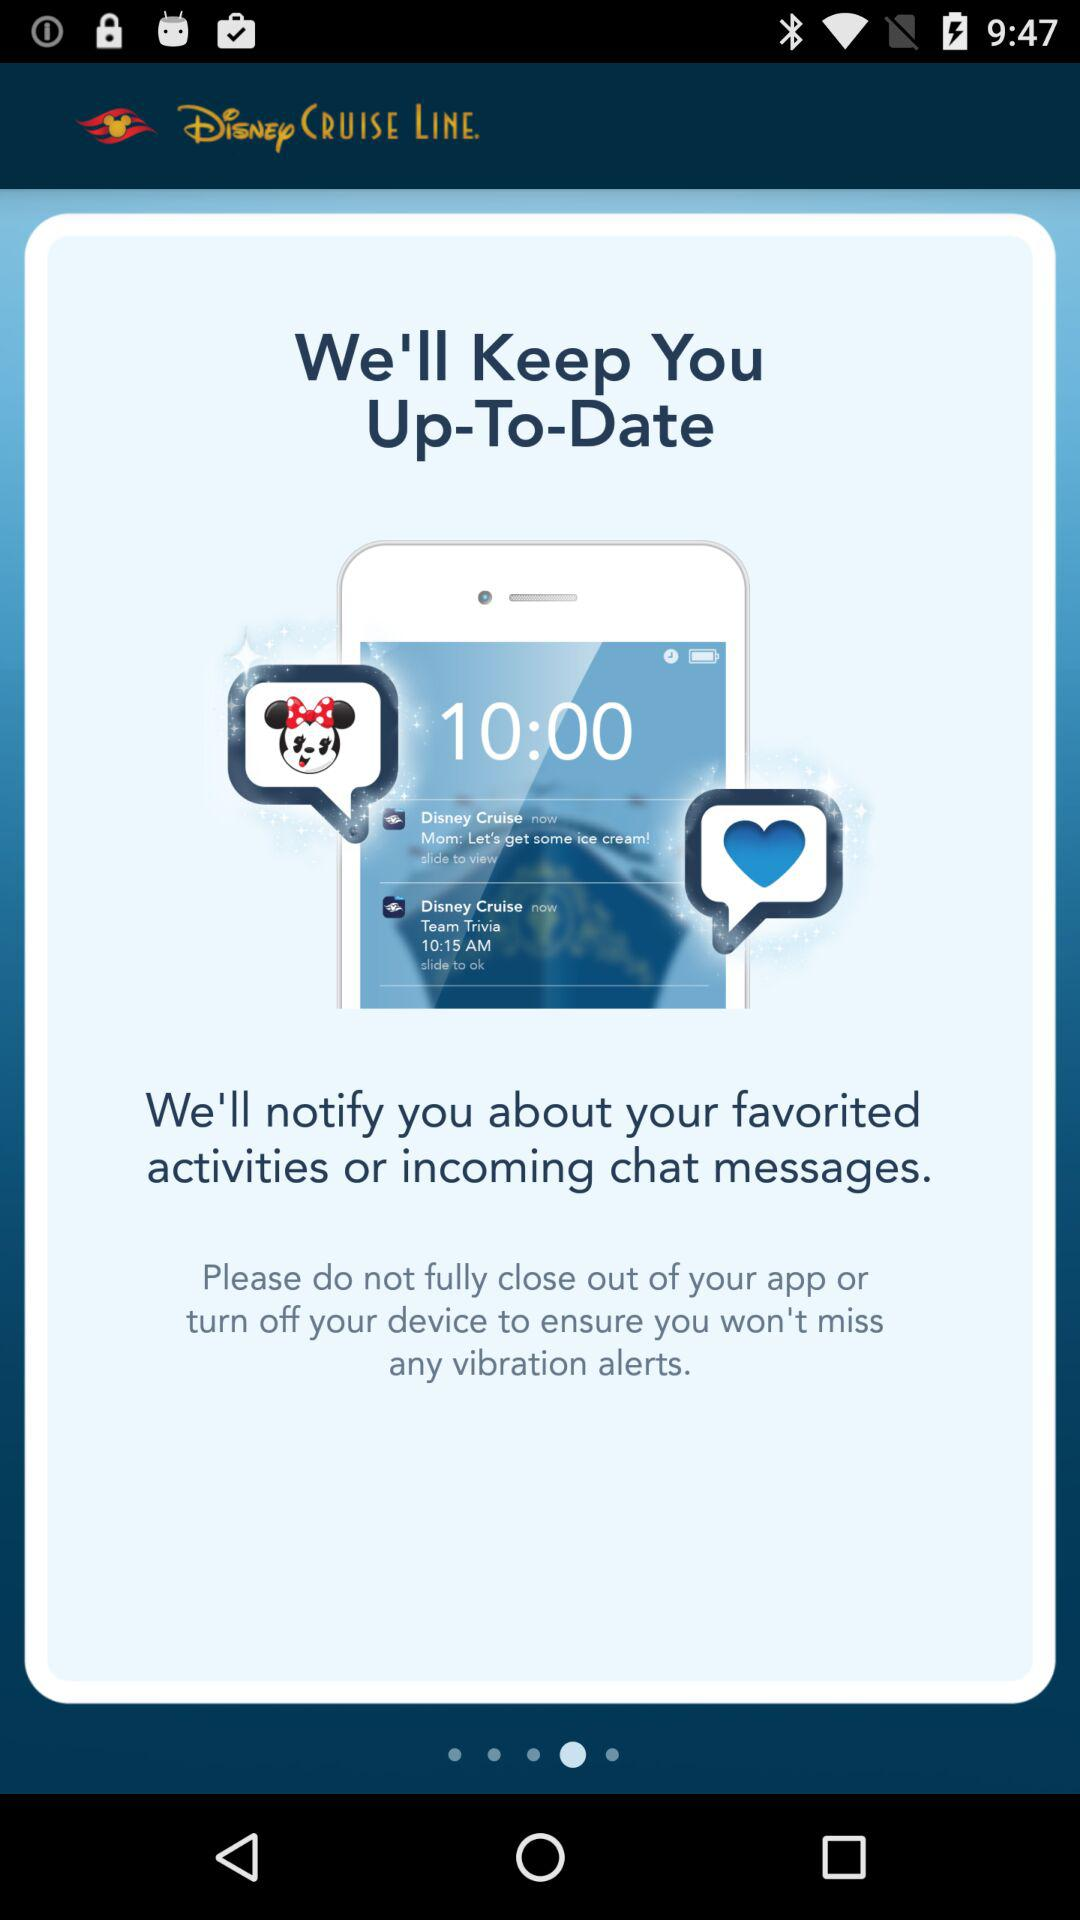What time is shown on the screen? The time shown on the screen is 10:00. 